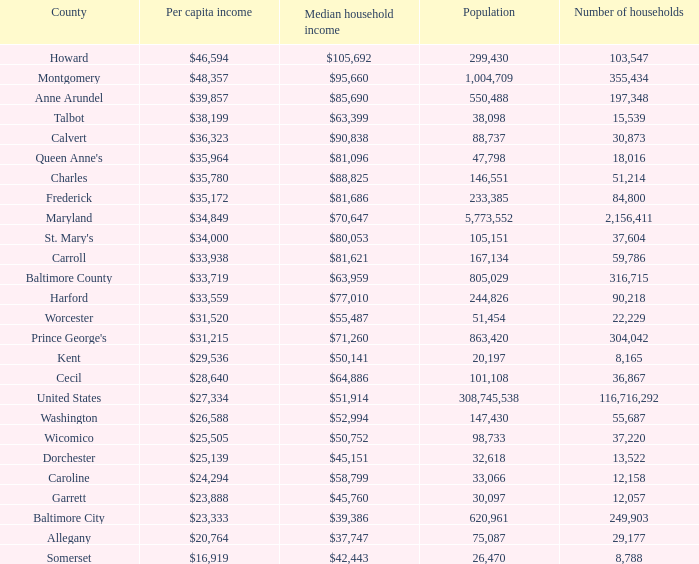What is the per capital income for Charles county? $35,780. 